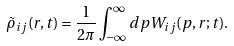<formula> <loc_0><loc_0><loc_500><loc_500>\tilde { \rho } _ { i j } ( r , t ) = \frac { 1 } { 2 \pi } \int _ { - \infty } ^ { \infty } d p W _ { i j } ( p , r ; t ) .</formula> 